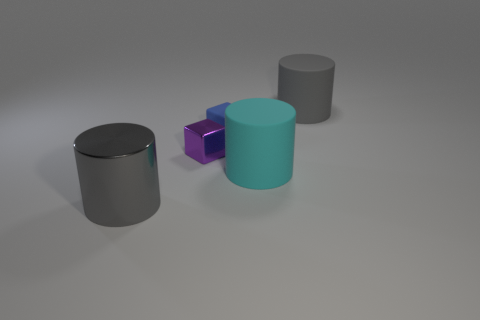The shiny cube is what color?
Ensure brevity in your answer.  Purple. There is a big object to the left of the rubber cube; does it have the same shape as the large thing that is behind the tiny purple block?
Offer a very short reply. Yes. What is the color of the object that is to the left of the small purple cube?
Provide a succinct answer. Gray. Are there fewer large gray matte cylinders in front of the large cyan cylinder than cylinders on the left side of the big gray rubber object?
Your answer should be compact. Yes. What number of other objects are there of the same material as the tiny blue cube?
Ensure brevity in your answer.  2. Are the blue cube and the cyan cylinder made of the same material?
Your answer should be very brief. Yes. How many other things are there of the same size as the blue rubber block?
Give a very brief answer. 1. There is a metal thing that is to the right of the gray thing in front of the large cyan matte object; what is its size?
Offer a terse response. Small. There is a shiny object that is behind the gray cylinder left of the small object in front of the tiny blue cube; what is its color?
Keep it short and to the point. Purple. How big is the cylinder that is both to the right of the gray shiny thing and in front of the big gray matte thing?
Keep it short and to the point. Large. 